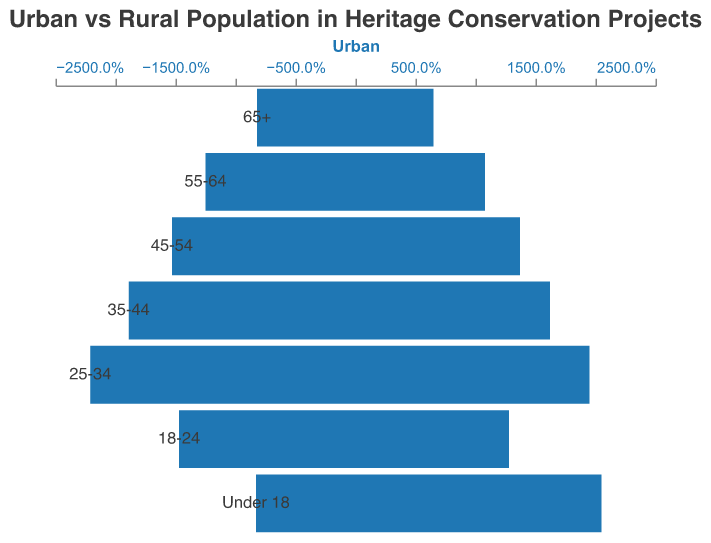How many different age groups are represented in the figure? The figure displays data for each age group separately. Counting the distinct age groups listed in the vertical axis (y-axis), we find there are 7 age groups.
Answer: 7 Which age group has the highest urban population percentage? Look at the bar length for the urban population (blue bar) and compare them across all age groups. The age group 25-34 has the longest blue bar, representing the highest urban population percentage.
Answer: 25-34 What is the difference in population percentage between urban and rural for the age group Under 18? For the age group Under 18, the urban population percentage is 8.3% and rural is 20.5%. The difference is calculated by subtracting the urban percentage from the rural percentage: 20.5% - 8.3% = 12.2%.
Answer: 12.2% Which has a higher percentage of the population involved in heritage conservation for the age group 65+, urban or rural? For the age group 65+, the urban population percentage is 8.2%, and the rural population percentage is 6.5%. Compare these values, and it is evident that the urban percentage is higher.
Answer: Urban Calculate the average percentage of urban populations across all age groups. Sum the urban population percentages for all age groups: 8.2% + 12.5% + 15.3% + 18.9% + 22.1% + 14.7% + 8.3%. The total is 100%. Then, divide by the number of age groups, which is 7. The average is 100% / 7 ≈ 14.3%.
Answer: 14.3% Which age group shows a greater percentage difference between urban and rural populations, the 35-44 age group or the 45-54 age group? For the 35-44 age group, the urban percentage is 18.9% and the rural is 16.2%, with a difference of 18.9% - 16.2% = 2.7%. For the 45-54 age group, the urban percentage is 15.3% and the rural is 13.7%, with a difference of 15.3% - 13.7% = 1.6%. Comparing these differences, 2.7% is larger than 1.6%.
Answer: 35-44 Which age group has the smallest difference between urban and rural populations? Compare the urban and rural population percentages for each age group and calculate the differences: 65+ (8.2% - 6.5% = 1.7%), 55-64 (12.5% - 10.8% = 1.7%), 45-54 (15.3% - 13.7% = 1.6%), 35-44 (18.9% - 16.2% = 2.7%), 25-34 (22.1% - 19.5% = 2.6%), 18-24 (14.7% - 12.8% = 1.9%), Under 18 (20.5% - 8.3% = 12.2%). The smallest difference is 1.6% for the 45-54 age group.
Answer: 45-54 Is the rural population percentage higher than the urban population percentage in any age group? Look at the bar lengths for each age group. The rural bar (orange bar) is longer than the urban bar (blue bar) only for the 'Under 18' age group.
Answer: Yes 